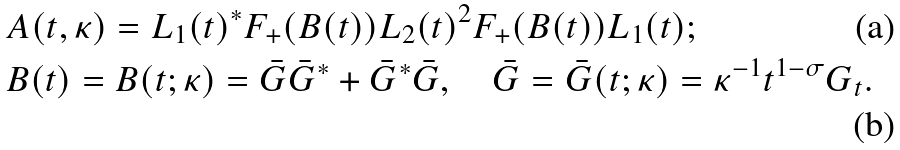<formula> <loc_0><loc_0><loc_500><loc_500>& A { \left ( t , \kappa \right ) } = L _ { 1 } { \left ( t \right ) } ^ { * } F _ { + } { \left ( B { \left ( t \right ) } \right ) } L _ { 2 } { \left ( t \right ) } ^ { 2 } F _ { + } { \left ( B { \left ( t \right ) } \right ) } L _ { 1 } { \left ( t \right ) } ; \\ & B { \left ( t \right ) } = B { \left ( t ; \kappa \right ) } = \bar { G } \bar { G } ^ { * } + \bar { G } ^ { * } \bar { G } , \quad \bar { G } = \bar { G } { \left ( t ; \kappa \right ) } = \kappa ^ { - 1 } t ^ { 1 - \sigma } G _ { t } .</formula> 